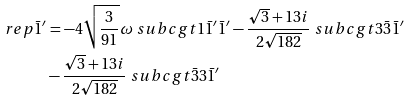<formula> <loc_0><loc_0><loc_500><loc_500>\ r e p { \bar { 1 } ^ { \prime } } & = - 4 \sqrt { \frac { 3 } { 9 1 } } \omega \ s u b c g t { 1 } { \bar { 1 } ^ { \prime } } { \bar { 1 } ^ { \prime } } - \frac { \sqrt { 3 } + 1 3 i } { 2 \sqrt { 1 8 2 } } \ s u b c g t { 3 } { \bar { 3 } } { \bar { 1 } ^ { \prime } } \\ & - \frac { \sqrt { 3 } + 1 3 i } { 2 \sqrt { 1 8 2 } } \ s u b c g t { \bar { 3 } } { 3 } { \bar { 1 } ^ { \prime } }</formula> 